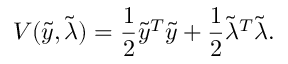<formula> <loc_0><loc_0><loc_500><loc_500>V ( \tilde { y } , \tilde { \lambda } ) = \frac { 1 } { 2 } \tilde { y } ^ { T } \tilde { y } + \frac { 1 } { 2 } \tilde { \lambda } ^ { T } \tilde { \lambda } .</formula> 